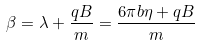Convert formula to latex. <formula><loc_0><loc_0><loc_500><loc_500>\beta = \lambda + \frac { q B } { m } = \frac { 6 { \pi } b { \eta } + q B } { m }</formula> 